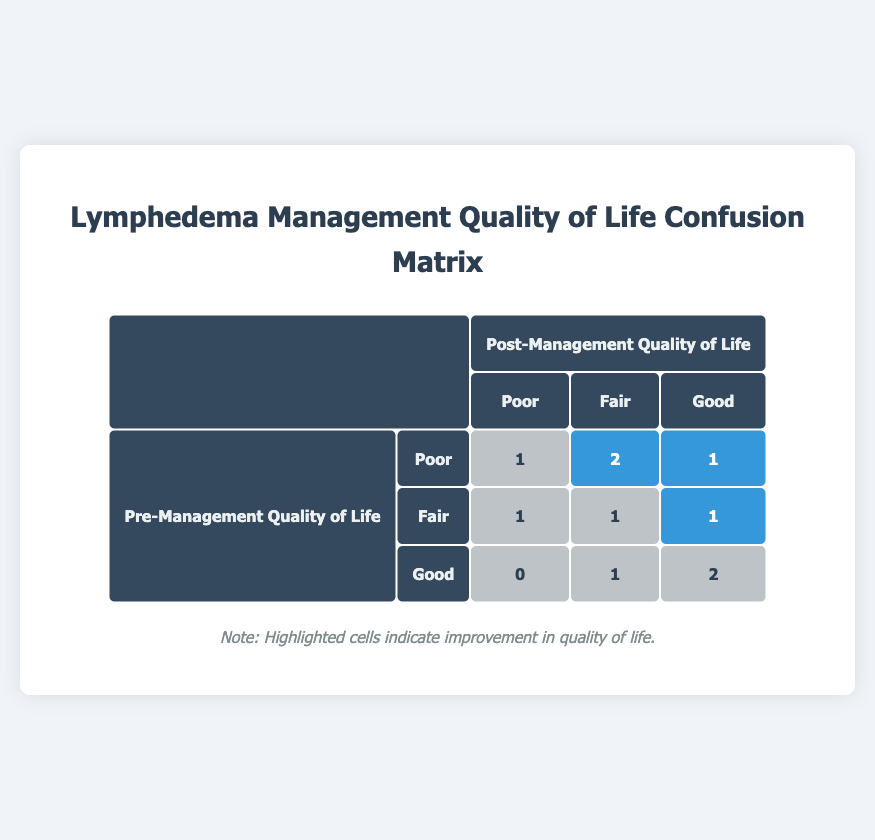What is the total number of patients with poor quality of life pre-management? From the table, we look at the "Poor" category under "Pre-Management Quality of Life". There are three patients (P001, P004, P006, P009) listed here, so the total is 4.
Answer: 4 How many patients showed an improvement in their quality of life after management? We can identify improvements by looking for "Yes" under the "Improvement" category. There are three patients (P001, P002, P006, P009) who showed improvement, so the total is 4.
Answer: 4 What is the number of patients who had a good quality of life both pre- and post-management? This can be found under the "Good" category in both the pre-management and post-management columns. There are two patients (P003, P010) who had "Good" quality of life before and after.
Answer: 2 How many patients with poor pre-management quality of life improved to good post-management? We check the "Poor" row in the pre-management section and look for instances where the post-management quality of life is "Good". Only one patient (P006) meets this criterion.
Answer: 1 Is there any patient who improved from fair to good? We examine the patients who had a "Fair" pre-management quality of life and look for "Good" in the post-management column. Patient P002 improved from Fair to Good, confirming that the answer is Yes.
Answer: Yes What percentage of patients had a fair quality of life pre-management? Count the number of patients in the "Fair" pre-management category, which is three (P002, P005, P007) out of ten total patients. Hence, the percentage is (3/10) * 100 = 30%.
Answer: 30% How many patients experienced no change in their quality of life? We can gather those marked as "No" under the Improvement category, which amounts to five patients (P003, P004, P005, P007, P008).
Answer: 5 What is the breakdown of post-management quality of life among the patients who showed improvement? Patients who showed improvement are P001, P002, P006, P009. Among them, the breakdown is: Good: 2 (P002, P006), Fair: 2 (P001, P009).
Answer: Good: 2, Fair: 2 What is the total number of patients who remained in the same pre-management and post-management quality of life categories? We look at patients where the pre- and post-management values match; these patients are P003, P004, P005, P007, P010, giving us a total of 5 who stayed the same.
Answer: 5 